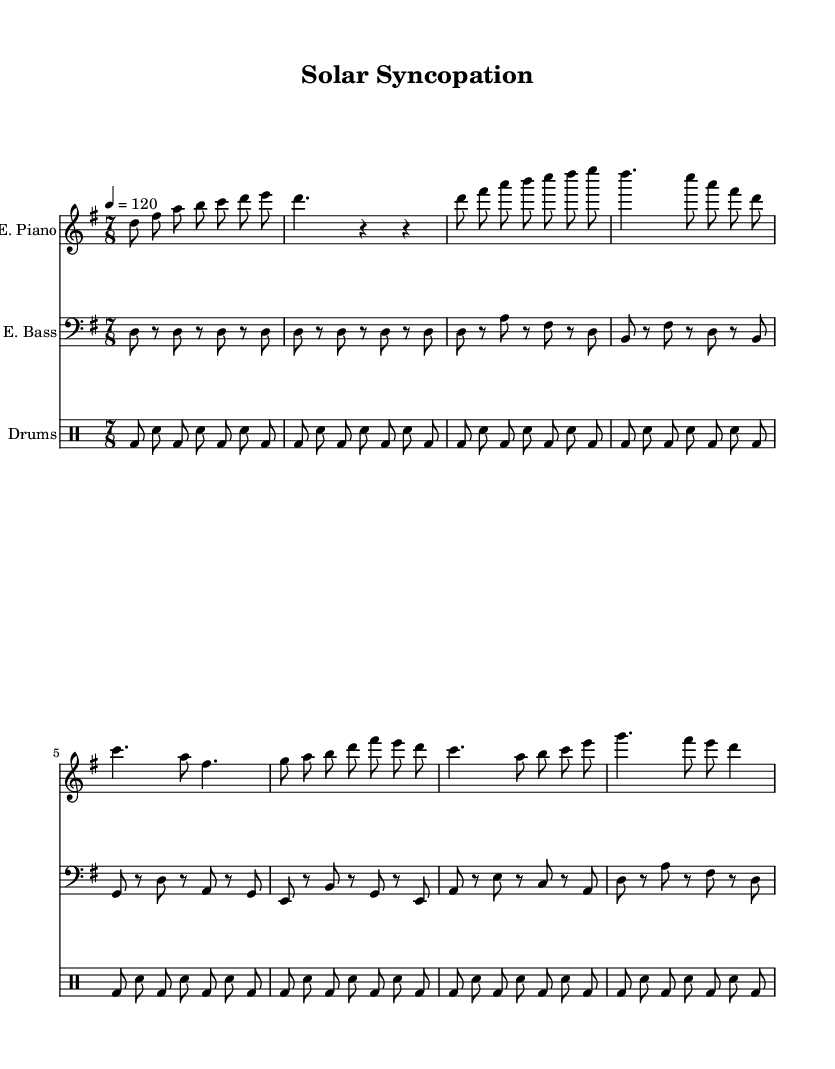What is the key signature of this music? The key signature is D mixolydian, which typically contains two sharps (F# and C#). This is identified by analyzing the note markings at the beginning of the staff.
Answer: D mixolydian What is the time signature of this music? The time signature is 7/8, indicated next to the clef at the beginning of the score. This shows that each measure contains seven eighth-note beats.
Answer: 7/8 What is the tempo marking for this piece? The tempo marking is quarter note equals 120, which can be found at the beginning of the score. This indicates the speed of the music, given as the number of beats per minute.
Answer: 120 How many sections are there in this piece? There are two main sections labeled as A and B in the music. This can be determined by looking for labeled transitions in the music.
Answer: 2 What instruments are included in the arrangement? The arrangement includes an electric piano, electric bass, and drums; this is evident from the headers for each staff in the score.
Answer: Electric piano, electric bass, drums In which section does the electric bass play a different rhythm from the electric piano? The electric bass plays a different rhythm during the B section compared to the electric piano. This involves comparing the rhythms visually in the respective sections of the score.
Answer: B section What unique element do we observe in the drum pattern? The drum pattern features a consistent bass drum and snare rhythm throughout, which is common in jazz music for maintaining groove. This can be analyzed by noting the absence of complex fills.
Answer: Consistent bass and snare rhythm 